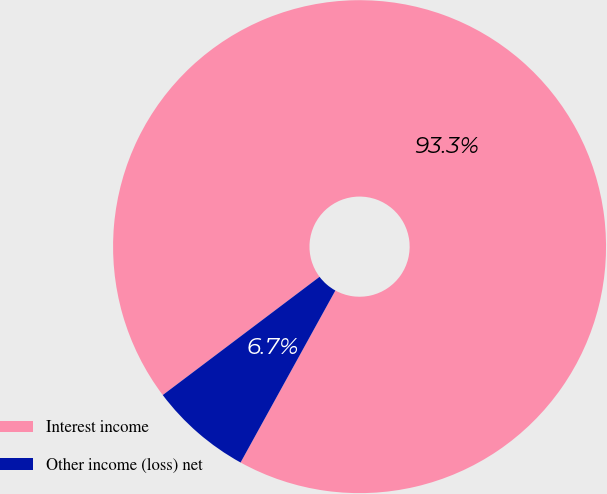<chart> <loc_0><loc_0><loc_500><loc_500><pie_chart><fcel>Interest income<fcel>Other income (loss) net<nl><fcel>93.3%<fcel>6.7%<nl></chart> 